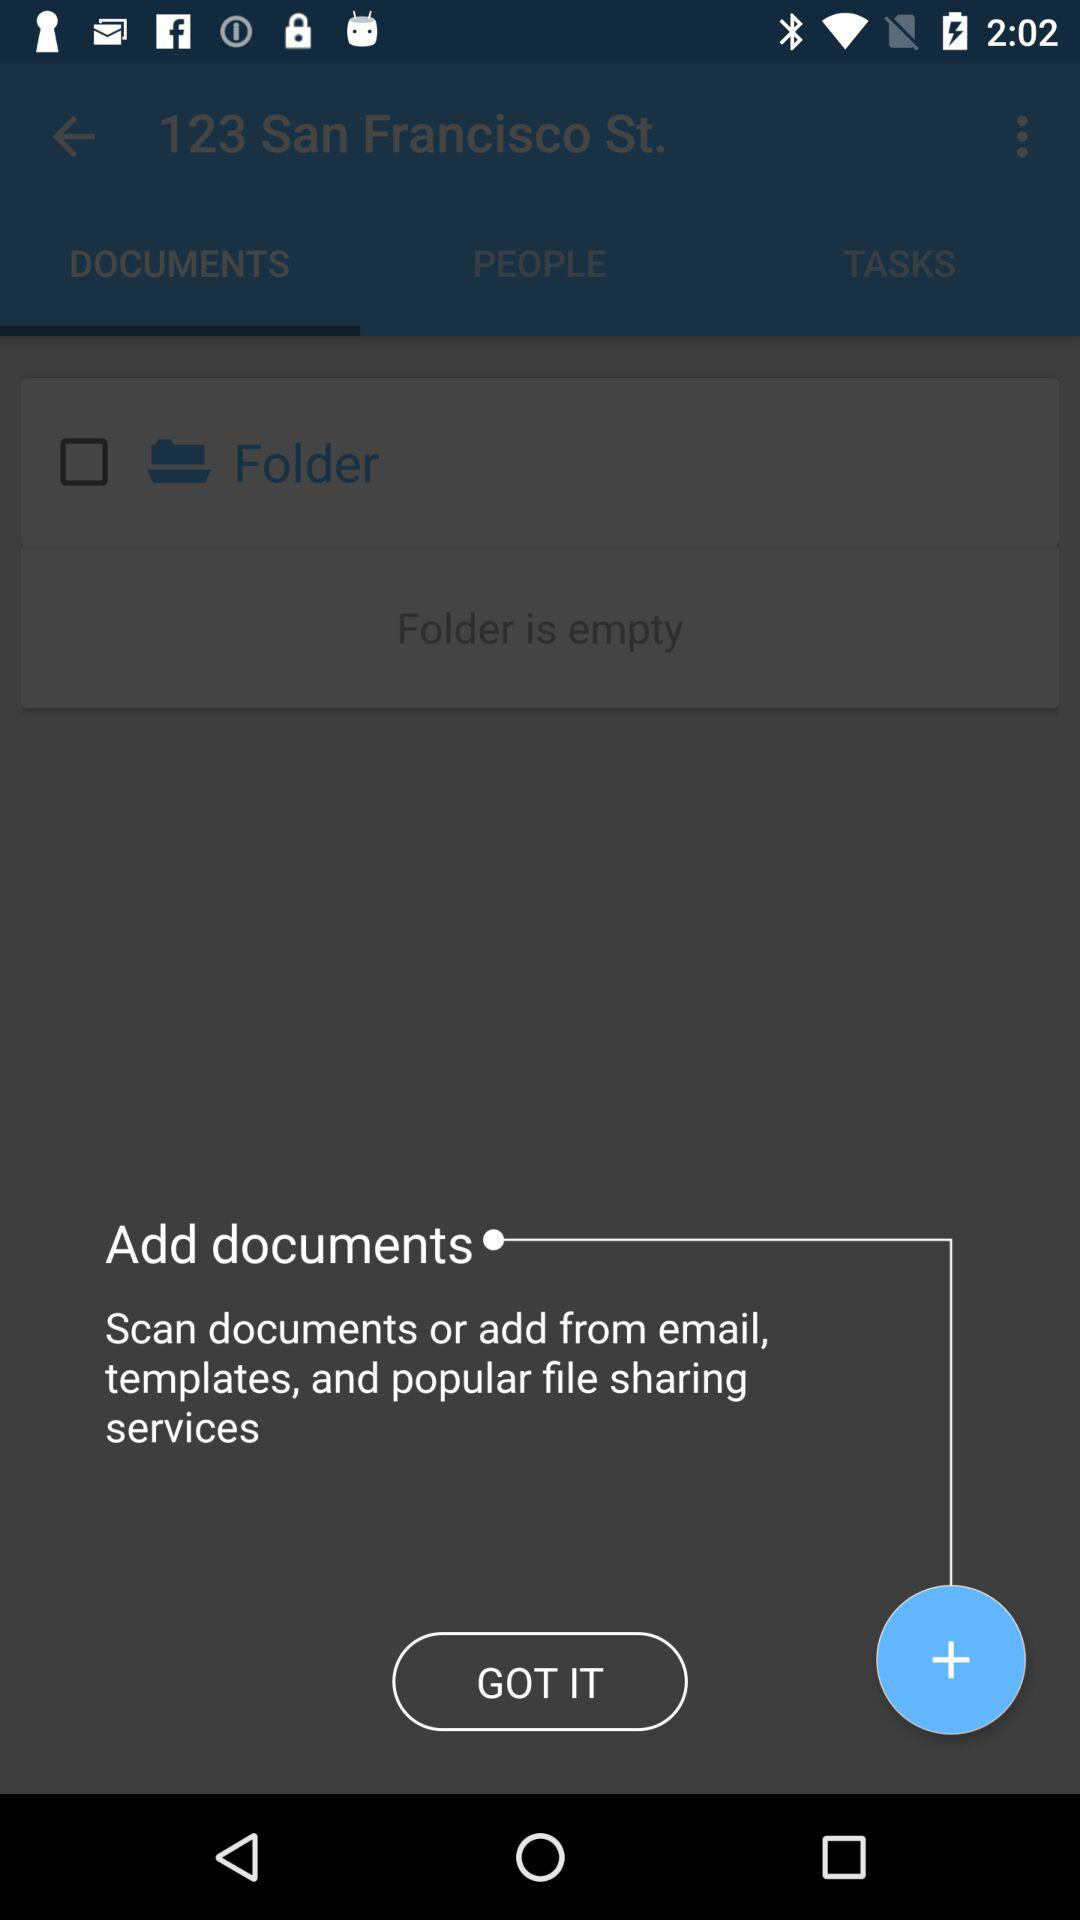Which tab is selected? The selected tab is "DOCUMENTS". 